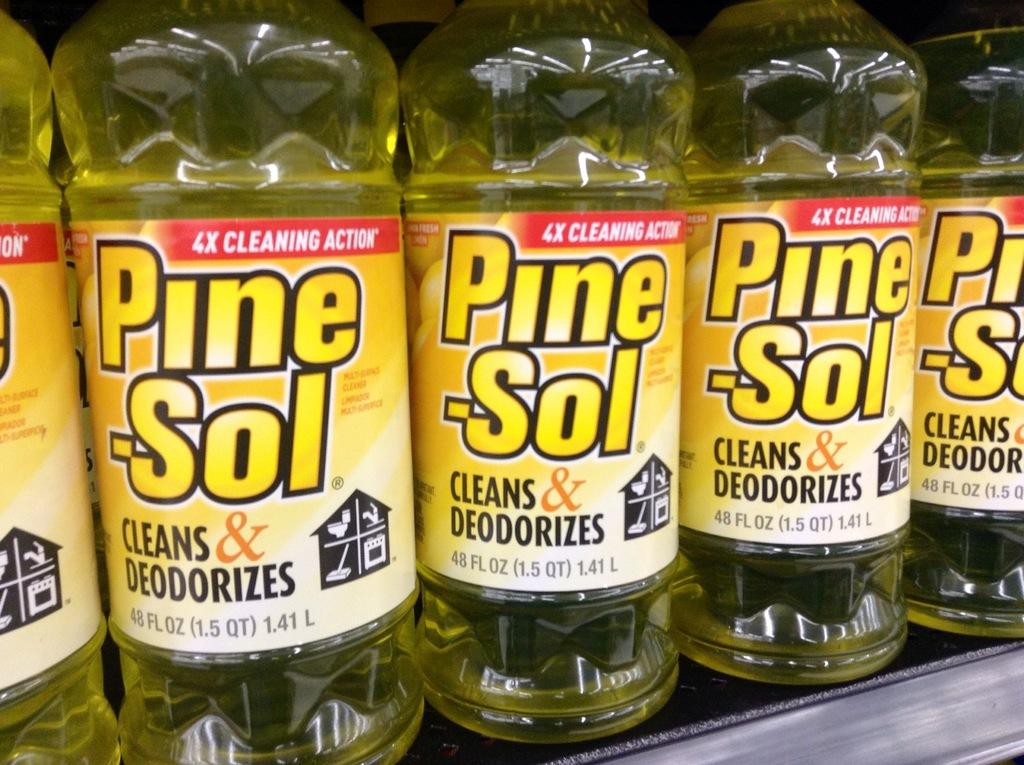What objects are present in the image? There are bottles in the image. What type of gold can be seen in the image? There is no gold present in the image; it only features bottles. What is the aftermath of the spade in the image? There is no spade present in the image, so it's not possible to determine the aftermath of its use. 